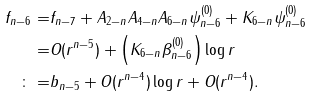Convert formula to latex. <formula><loc_0><loc_0><loc_500><loc_500>f _ { n - 6 } = & f _ { n - 7 } + A _ { 2 - n } A _ { 4 - n } A _ { 6 - n } \psi _ { n - 6 } ^ { ( 0 ) } + K _ { 6 - n } \psi _ { n - 6 } ^ { ( 0 ) } \\ = & O ( r ^ { n - 5 } ) + \left ( K _ { 6 - n } \beta _ { n - 6 } ^ { ( 0 ) } \right ) \log r \\ \colon = & b _ { n - 5 } + O ( r ^ { n - 4 } ) \log r + O ( r ^ { n - 4 } ) .</formula> 